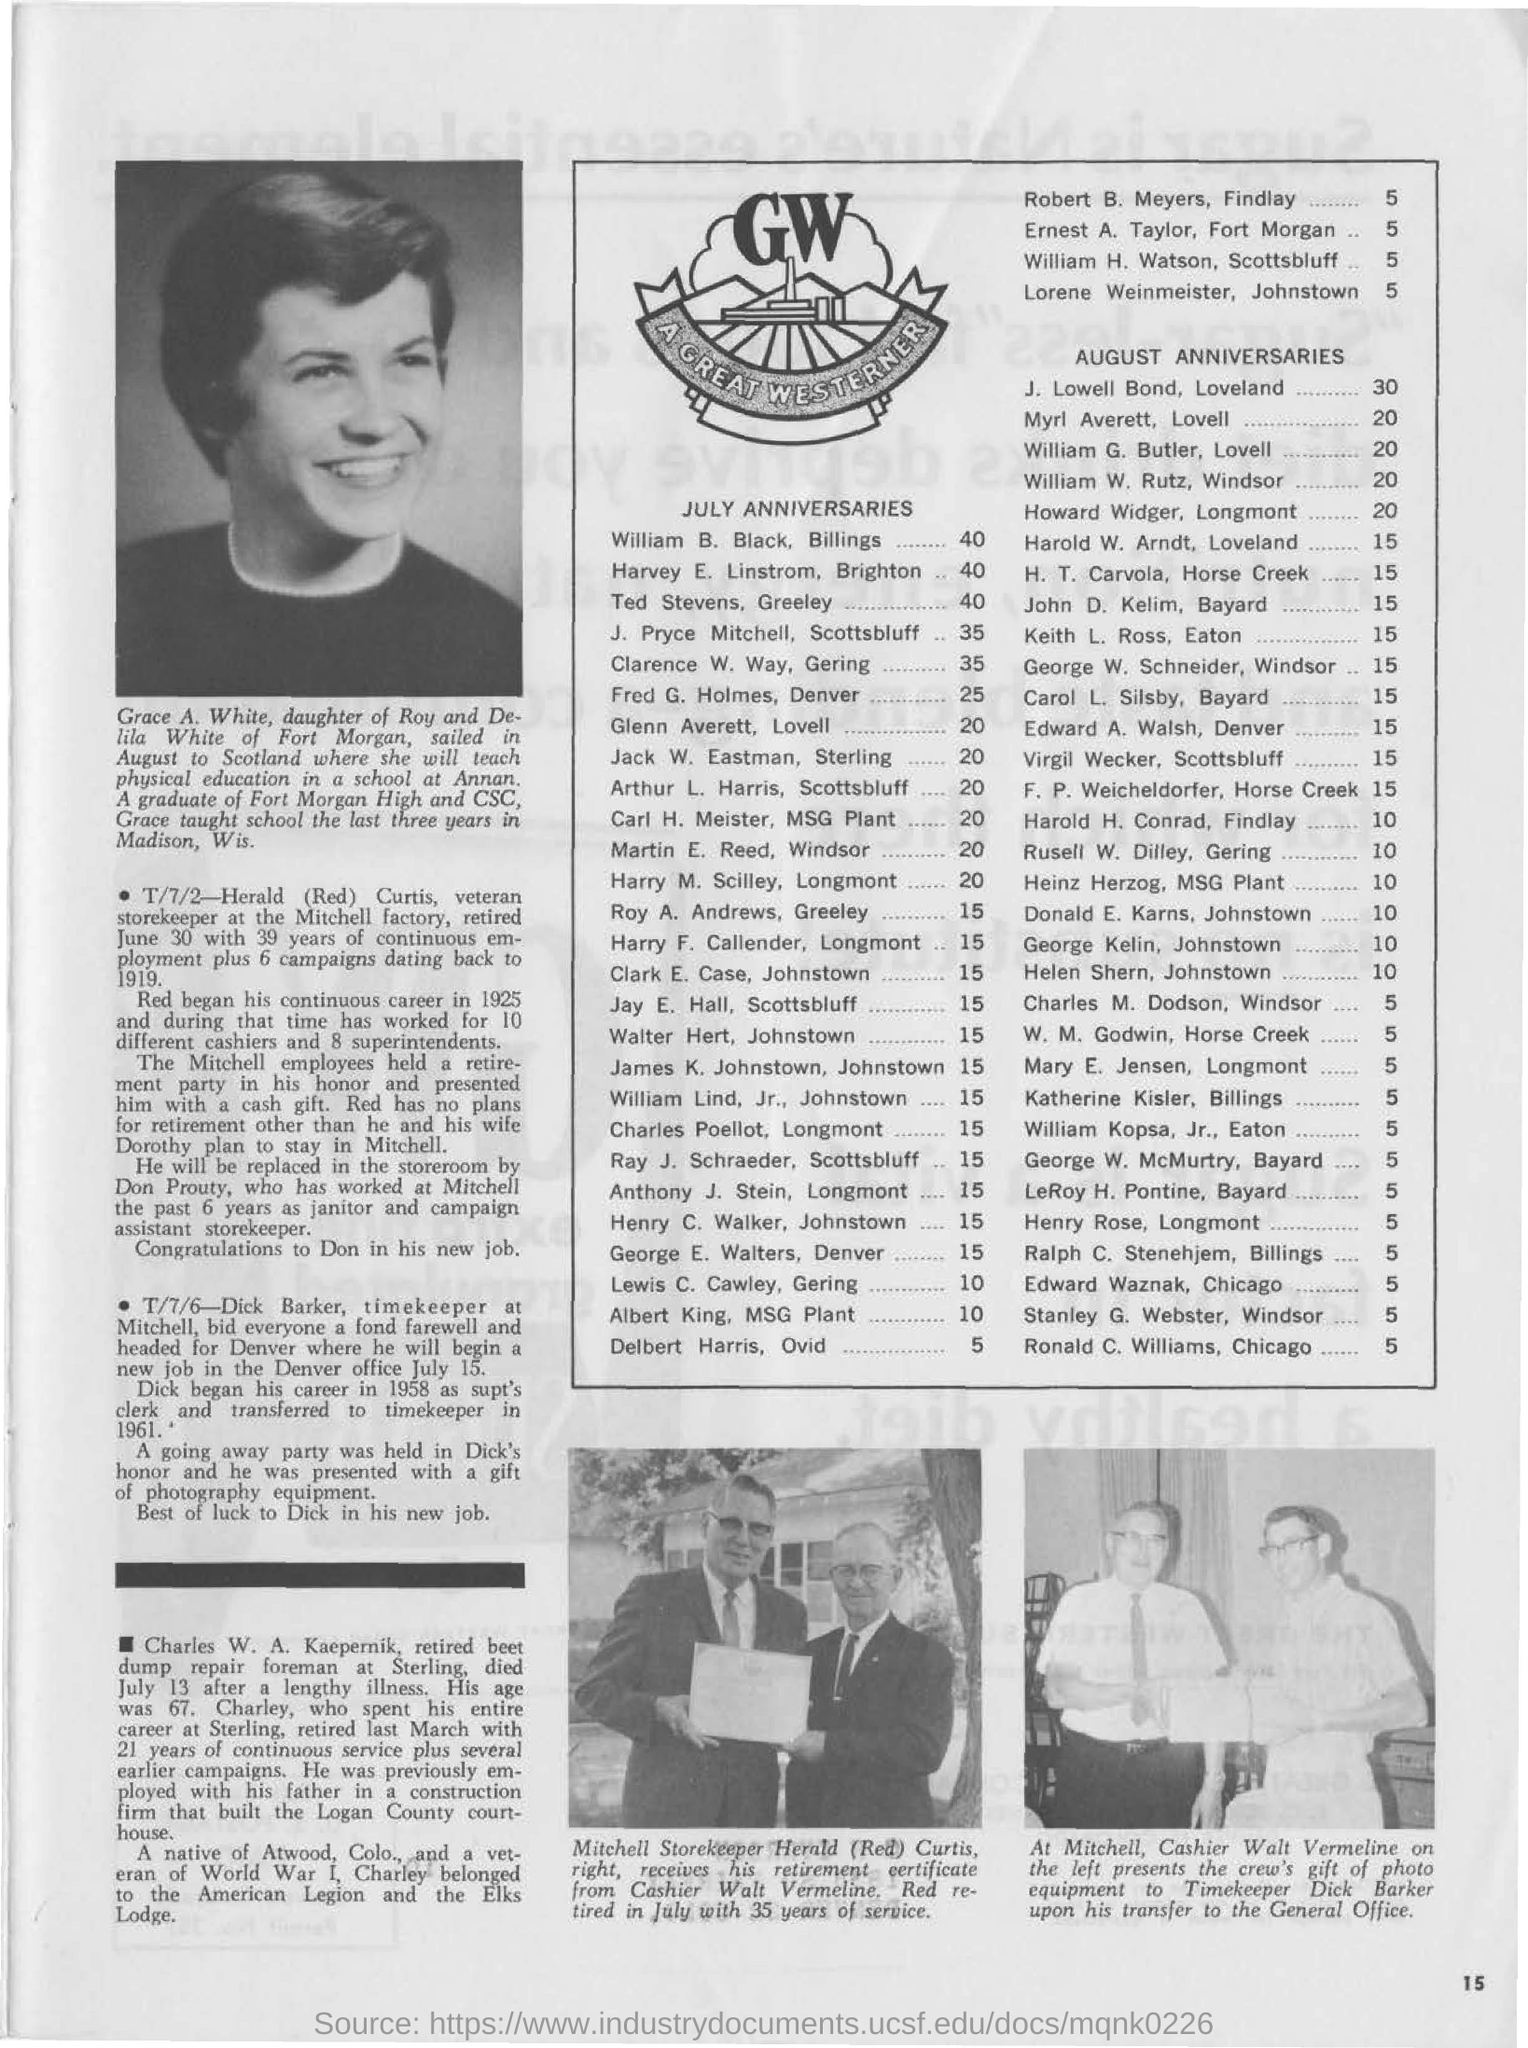Specify some key components in this picture. John Lowell Bond's anniversary is in August. The month in which J. Pryce Mitchell's anniversary falls is July. August is Myra Averett's anniversary month. 